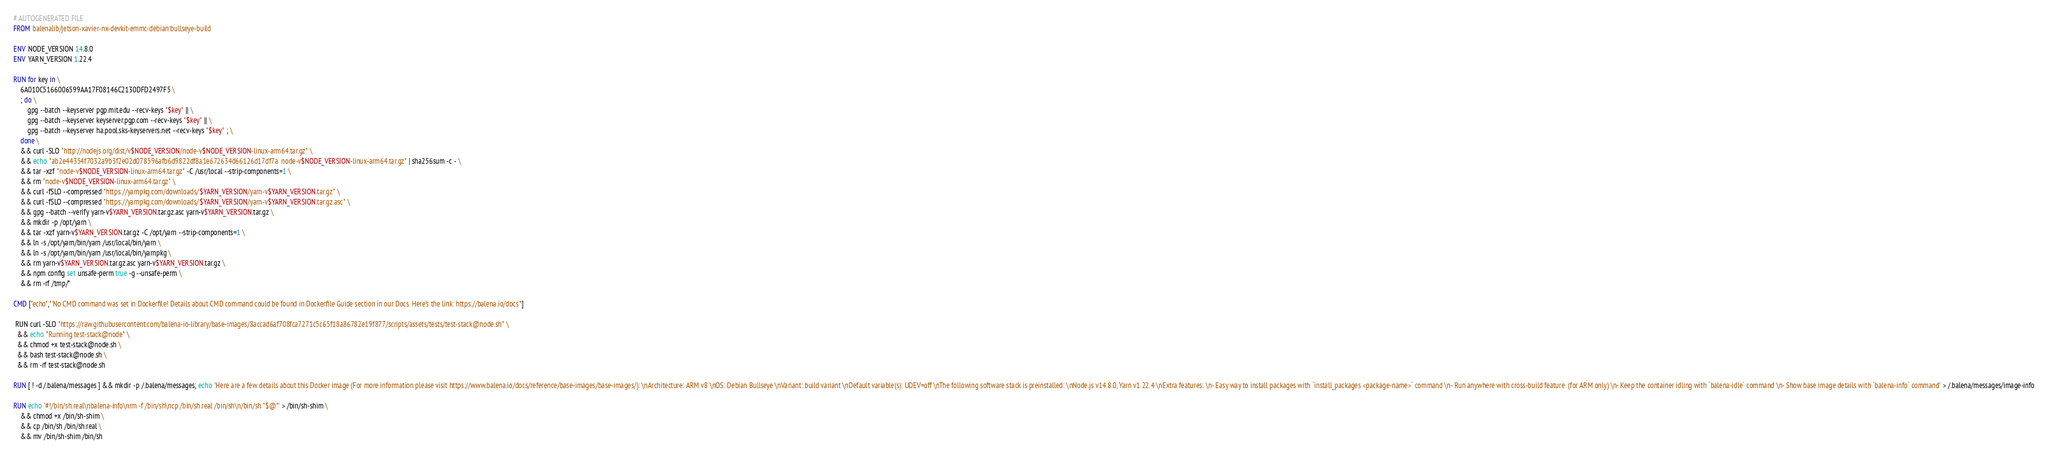<code> <loc_0><loc_0><loc_500><loc_500><_Dockerfile_># AUTOGENERATED FILE
FROM balenalib/jetson-xavier-nx-devkit-emmc-debian:bullseye-build

ENV NODE_VERSION 14.8.0
ENV YARN_VERSION 1.22.4

RUN for key in \
	6A010C5166006599AA17F08146C2130DFD2497F5 \
	; do \
		gpg --batch --keyserver pgp.mit.edu --recv-keys "$key" || \
		gpg --batch --keyserver keyserver.pgp.com --recv-keys "$key" || \
		gpg --batch --keyserver ha.pool.sks-keyservers.net --recv-keys "$key" ; \
	done \
	&& curl -SLO "http://nodejs.org/dist/v$NODE_VERSION/node-v$NODE_VERSION-linux-arm64.tar.gz" \
	&& echo "ab2e44354f7032a9b3f2e02d078596afb6d9822df8a1e672634d66126d17df7a  node-v$NODE_VERSION-linux-arm64.tar.gz" | sha256sum -c - \
	&& tar -xzf "node-v$NODE_VERSION-linux-arm64.tar.gz" -C /usr/local --strip-components=1 \
	&& rm "node-v$NODE_VERSION-linux-arm64.tar.gz" \
	&& curl -fSLO --compressed "https://yarnpkg.com/downloads/$YARN_VERSION/yarn-v$YARN_VERSION.tar.gz" \
	&& curl -fSLO --compressed "https://yarnpkg.com/downloads/$YARN_VERSION/yarn-v$YARN_VERSION.tar.gz.asc" \
	&& gpg --batch --verify yarn-v$YARN_VERSION.tar.gz.asc yarn-v$YARN_VERSION.tar.gz \
	&& mkdir -p /opt/yarn \
	&& tar -xzf yarn-v$YARN_VERSION.tar.gz -C /opt/yarn --strip-components=1 \
	&& ln -s /opt/yarn/bin/yarn /usr/local/bin/yarn \
	&& ln -s /opt/yarn/bin/yarn /usr/local/bin/yarnpkg \
	&& rm yarn-v$YARN_VERSION.tar.gz.asc yarn-v$YARN_VERSION.tar.gz \
	&& npm config set unsafe-perm true -g --unsafe-perm \
	&& rm -rf /tmp/*

CMD ["echo","'No CMD command was set in Dockerfile! Details about CMD command could be found in Dockerfile Guide section in our Docs. Here's the link: https://balena.io/docs"]

 RUN curl -SLO "https://raw.githubusercontent.com/balena-io-library/base-images/8accad6af708fca7271c5c65f18a86782e19f877/scripts/assets/tests/test-stack@node.sh" \
  && echo "Running test-stack@node" \
  && chmod +x test-stack@node.sh \
  && bash test-stack@node.sh \
  && rm -rf test-stack@node.sh 

RUN [ ! -d /.balena/messages ] && mkdir -p /.balena/messages; echo 'Here are a few details about this Docker image (For more information please visit https://www.balena.io/docs/reference/base-images/base-images/): \nArchitecture: ARM v8 \nOS: Debian Bullseye \nVariant: build variant \nDefault variable(s): UDEV=off \nThe following software stack is preinstalled: \nNode.js v14.8.0, Yarn v1.22.4 \nExtra features: \n- Easy way to install packages with `install_packages <package-name>` command \n- Run anywhere with cross-build feature  (for ARM only) \n- Keep the container idling with `balena-idle` command \n- Show base image details with `balena-info` command' > /.balena/messages/image-info

RUN echo '#!/bin/sh.real\nbalena-info\nrm -f /bin/sh\ncp /bin/sh.real /bin/sh\n/bin/sh "$@"' > /bin/sh-shim \
	&& chmod +x /bin/sh-shim \
	&& cp /bin/sh /bin/sh.real \
	&& mv /bin/sh-shim /bin/sh</code> 